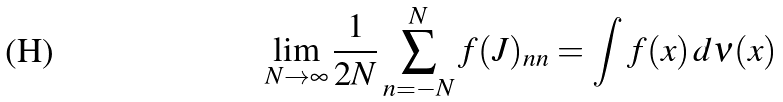Convert formula to latex. <formula><loc_0><loc_0><loc_500><loc_500>\lim _ { N \to \infty } \frac { 1 } { 2 N } \sum _ { n = - N } ^ { N } f ( J ) _ { n n } = \int f ( x ) \, d \nu ( x )</formula> 